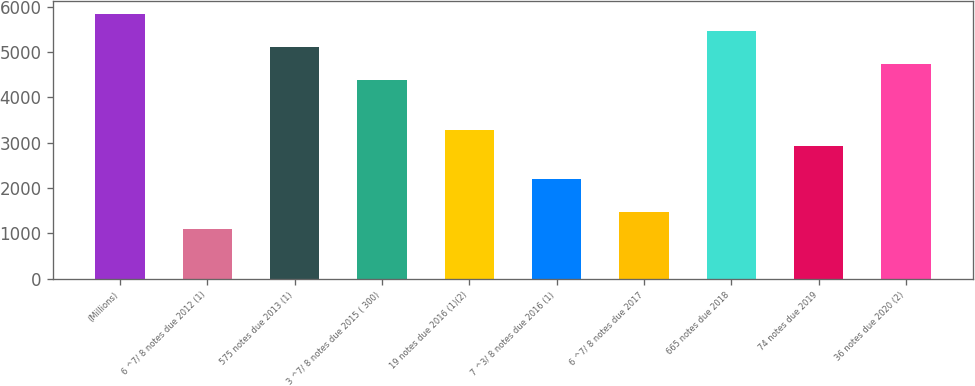Convert chart to OTSL. <chart><loc_0><loc_0><loc_500><loc_500><bar_chart><fcel>(Millions)<fcel>6 ^7/ 8 notes due 2012 (1)<fcel>575 notes due 2013 (1)<fcel>3 ^7/ 8 notes due 2015 ( 300)<fcel>19 notes due 2016 (1)(2)<fcel>7 ^3/ 8 notes due 2016 (1)<fcel>6 ^7/ 8 notes due 2017<fcel>665 notes due 2018<fcel>74 notes due 2019<fcel>36 notes due 2020 (2)<nl><fcel>5833<fcel>1101<fcel>5105<fcel>4377<fcel>3285<fcel>2193<fcel>1465<fcel>5469<fcel>2921<fcel>4741<nl></chart> 